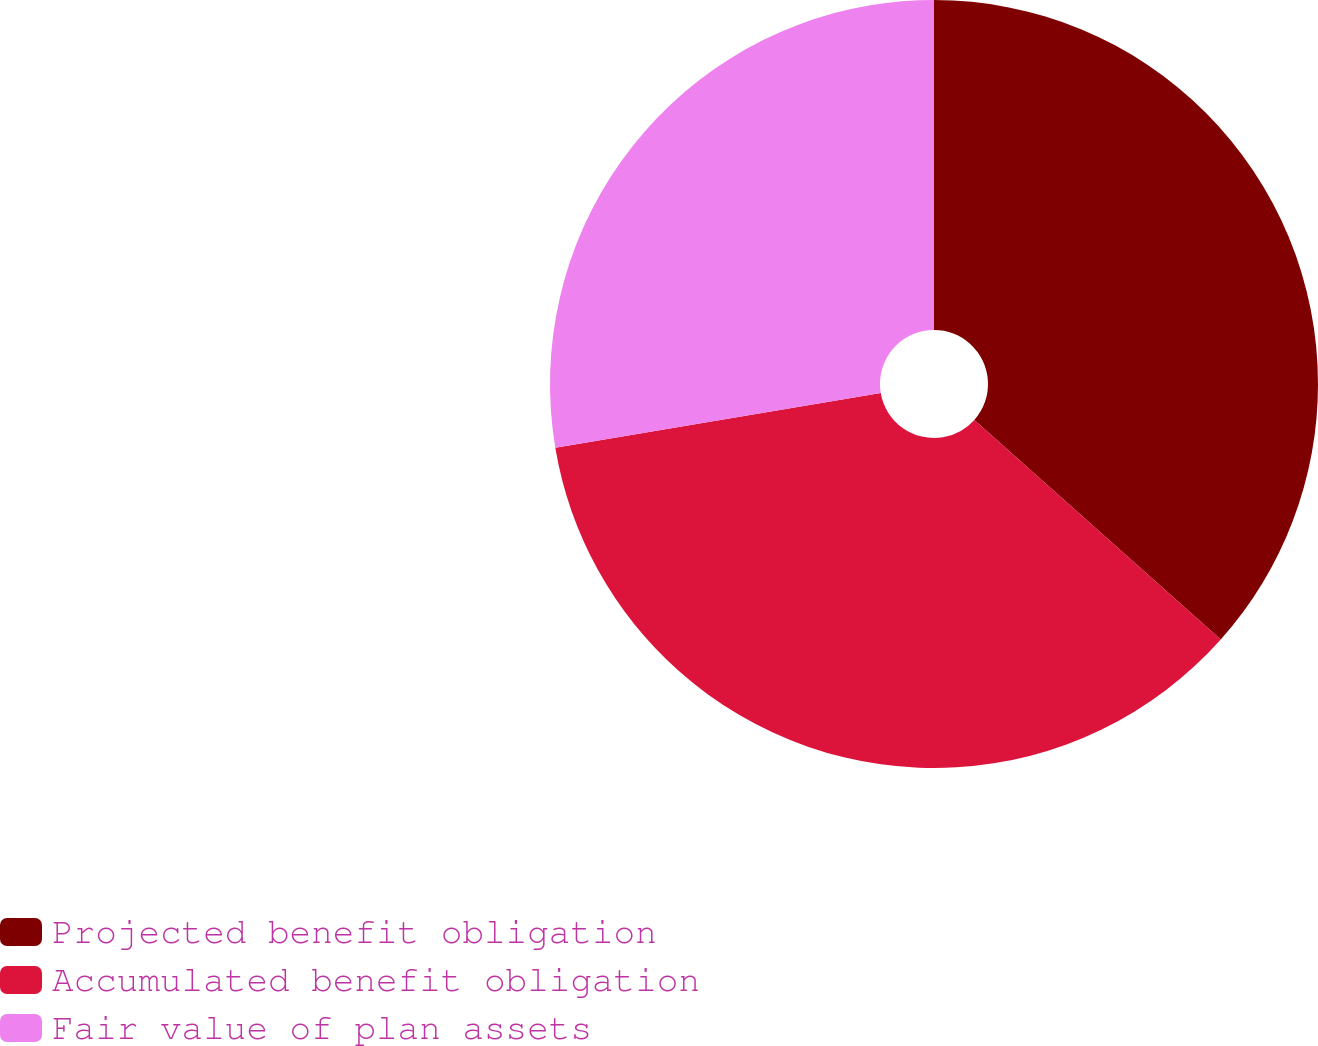<chart> <loc_0><loc_0><loc_500><loc_500><pie_chart><fcel>Projected benefit obligation<fcel>Accumulated benefit obligation<fcel>Fair value of plan assets<nl><fcel>36.58%<fcel>35.77%<fcel>27.65%<nl></chart> 